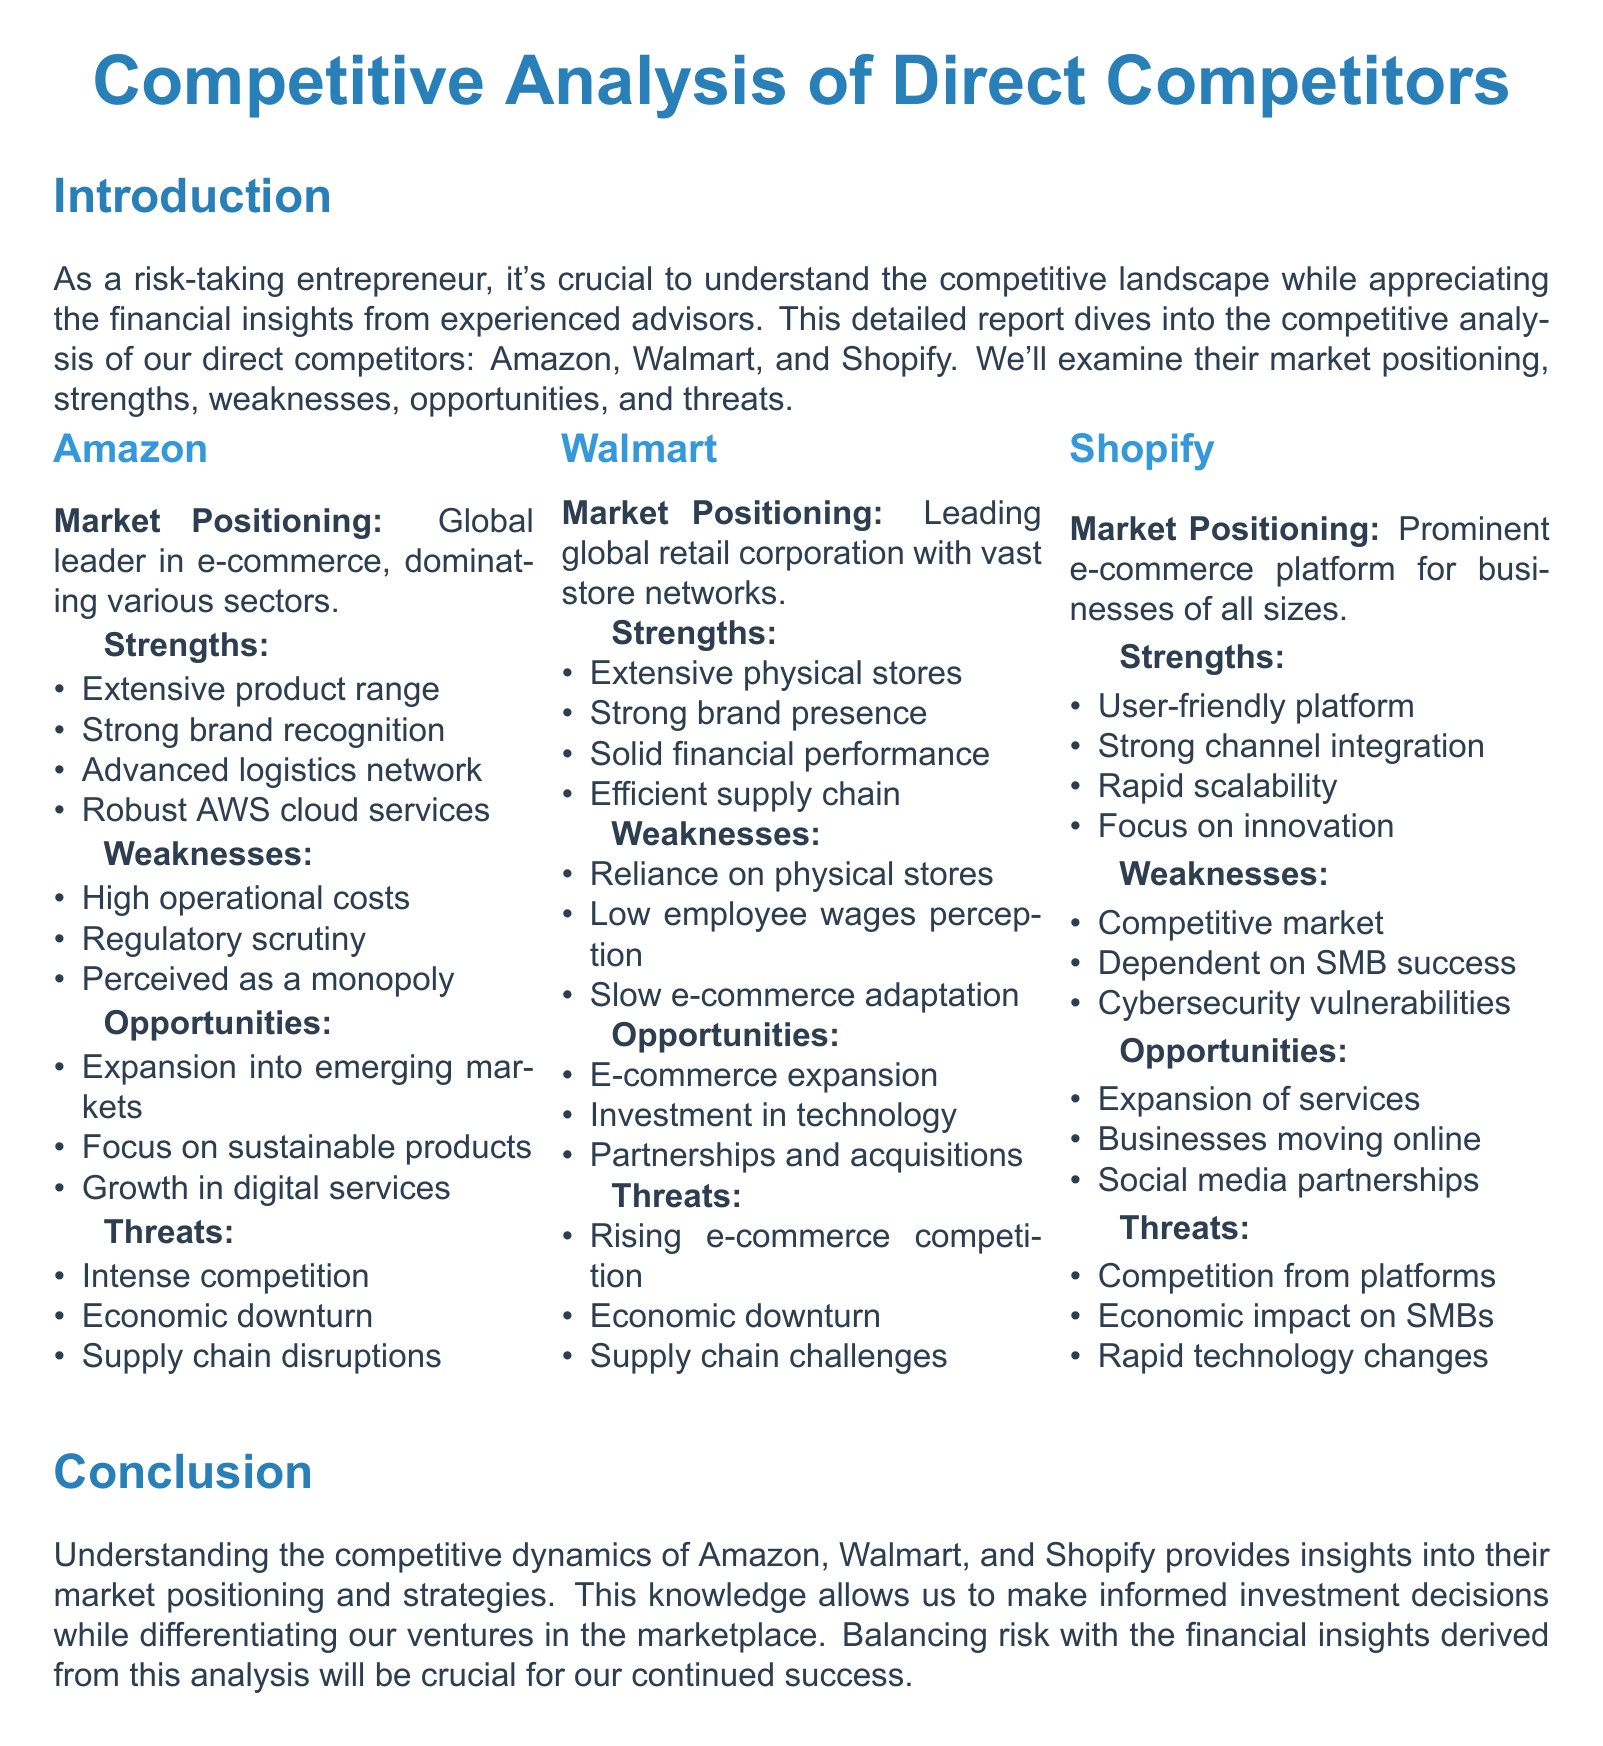What is Amazon's primary market positioning? Amazon's primary market positioning is as a global leader in e-commerce, dominating various sectors.
Answer: Global leader in e-commerce What are the opportunities identified for Walmart? The opportunities identified for Walmart include e-commerce expansion, investment in technology, and partnerships and acquisitions.
Answer: E-commerce expansion What is a weakness of Shopify? A weakness of Shopify is its dependency on the success of small and medium-sized businesses (SMBs).
Answer: Dependent on SMB success What strength is shared by both Amazon and Walmart? Both Amazon and Walmart share the strength of strong brand recognition/presence.
Answer: Strong brand recognition/presence What is the main threat to Shopify's growth? The main threat to Shopify's growth is competition from other platforms.
Answer: Competition from platforms What market position does Walmart hold? Walmart holds a leading position as a global retail corporation.
Answer: Leading global retail corporation What is a significant strength of Amazon's logistics? A significant strength of Amazon's logistics is its advanced logistics network.
Answer: Advanced logistics network What is the main focus area for Shopify's growth opportunities? The main focus area for Shopify's growth opportunities is the expansion of services.
Answer: Expansion of services What overarching factor affects Amazon's business as identified in the threats? Intense competition is an overarching factor that affects Amazon's business according to the threats identified.
Answer: Intense competition 